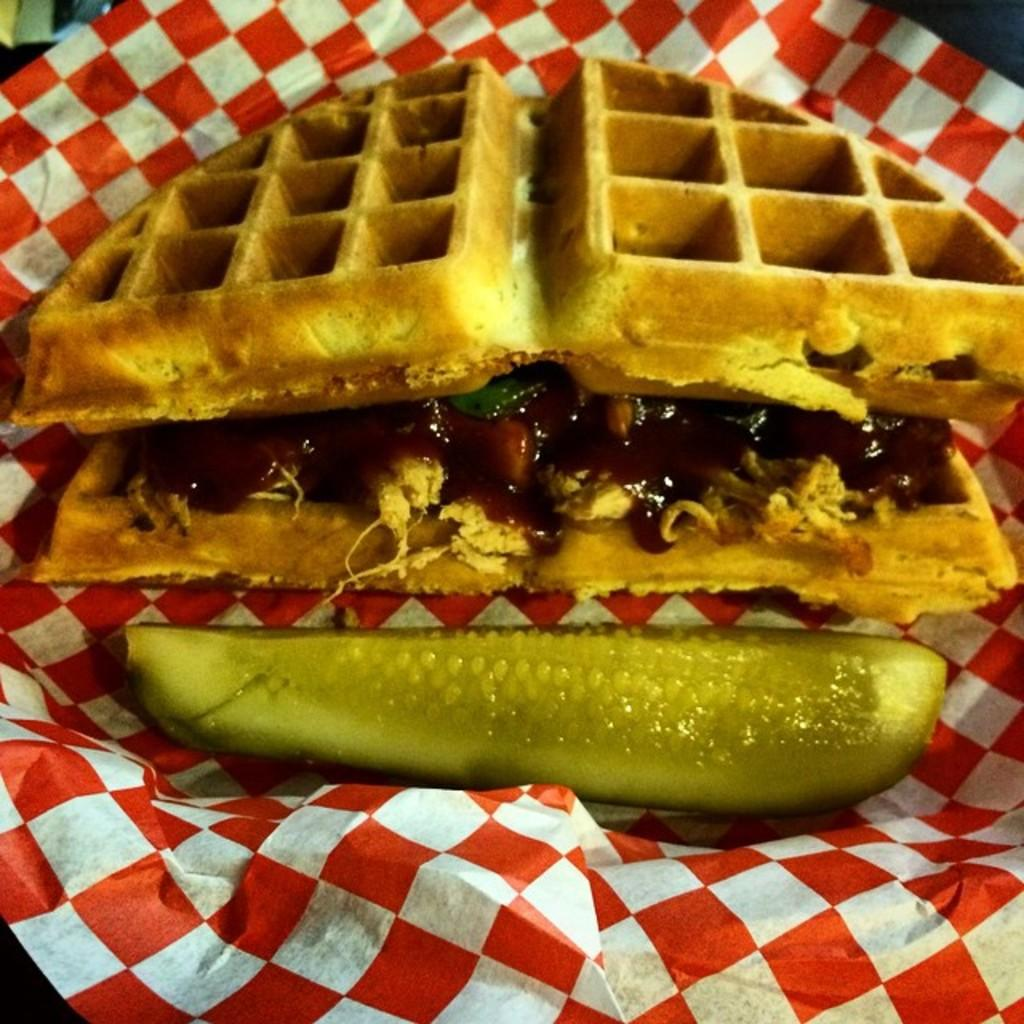What type of items can be seen in the image? There are food items in the image. How are the food items arranged or presented? The food items are placed on a paper. What type of love can be seen between the giants in the image? There are no giants or any indication of love in the image; it features food items placed on a paper. 